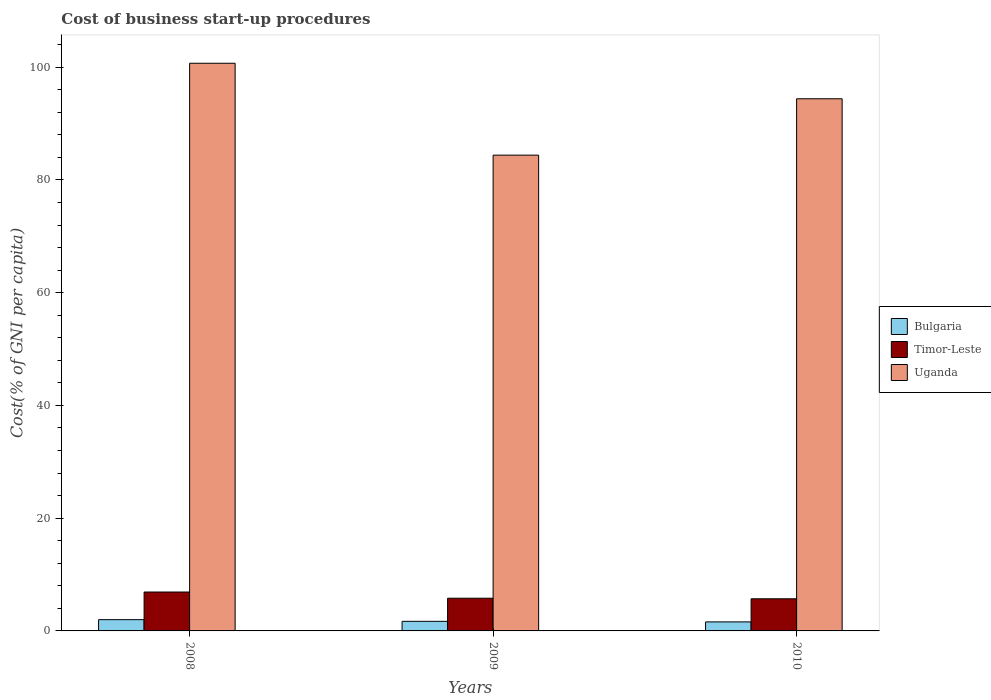How many different coloured bars are there?
Your answer should be compact. 3. How many groups of bars are there?
Provide a short and direct response. 3. Are the number of bars per tick equal to the number of legend labels?
Your answer should be very brief. Yes. Are the number of bars on each tick of the X-axis equal?
Provide a short and direct response. Yes. What is the label of the 2nd group of bars from the left?
Your answer should be compact. 2009. In how many cases, is the number of bars for a given year not equal to the number of legend labels?
Offer a terse response. 0. What is the cost of business start-up procedures in Uganda in 2010?
Your response must be concise. 94.4. Across all years, what is the maximum cost of business start-up procedures in Timor-Leste?
Provide a short and direct response. 6.9. In which year was the cost of business start-up procedures in Uganda maximum?
Ensure brevity in your answer.  2008. What is the total cost of business start-up procedures in Uganda in the graph?
Your answer should be compact. 279.5. What is the difference between the cost of business start-up procedures in Bulgaria in 2009 and that in 2010?
Give a very brief answer. 0.1. What is the difference between the cost of business start-up procedures in Uganda in 2008 and the cost of business start-up procedures in Bulgaria in 2009?
Give a very brief answer. 99. What is the average cost of business start-up procedures in Bulgaria per year?
Keep it short and to the point. 1.77. In the year 2008, what is the difference between the cost of business start-up procedures in Uganda and cost of business start-up procedures in Timor-Leste?
Provide a succinct answer. 93.8. What is the ratio of the cost of business start-up procedures in Bulgaria in 2008 to that in 2009?
Your response must be concise. 1.18. Is the difference between the cost of business start-up procedures in Uganda in 2008 and 2010 greater than the difference between the cost of business start-up procedures in Timor-Leste in 2008 and 2010?
Offer a very short reply. Yes. What is the difference between the highest and the second highest cost of business start-up procedures in Bulgaria?
Your answer should be very brief. 0.3. What is the difference between the highest and the lowest cost of business start-up procedures in Uganda?
Your answer should be very brief. 16.3. Is the sum of the cost of business start-up procedures in Uganda in 2009 and 2010 greater than the maximum cost of business start-up procedures in Bulgaria across all years?
Your response must be concise. Yes. What does the 1st bar from the right in 2008 represents?
Provide a succinct answer. Uganda. Is it the case that in every year, the sum of the cost of business start-up procedures in Timor-Leste and cost of business start-up procedures in Uganda is greater than the cost of business start-up procedures in Bulgaria?
Provide a short and direct response. Yes. How many bars are there?
Your answer should be very brief. 9. How many years are there in the graph?
Ensure brevity in your answer.  3. Does the graph contain any zero values?
Ensure brevity in your answer.  No. Does the graph contain grids?
Provide a succinct answer. No. What is the title of the graph?
Offer a terse response. Cost of business start-up procedures. What is the label or title of the X-axis?
Your answer should be very brief. Years. What is the label or title of the Y-axis?
Your answer should be compact. Cost(% of GNI per capita). What is the Cost(% of GNI per capita) of Timor-Leste in 2008?
Keep it short and to the point. 6.9. What is the Cost(% of GNI per capita) in Uganda in 2008?
Provide a succinct answer. 100.7. What is the Cost(% of GNI per capita) in Timor-Leste in 2009?
Offer a terse response. 5.8. What is the Cost(% of GNI per capita) in Uganda in 2009?
Offer a terse response. 84.4. What is the Cost(% of GNI per capita) of Bulgaria in 2010?
Make the answer very short. 1.6. What is the Cost(% of GNI per capita) in Timor-Leste in 2010?
Your answer should be very brief. 5.7. What is the Cost(% of GNI per capita) in Uganda in 2010?
Your response must be concise. 94.4. Across all years, what is the maximum Cost(% of GNI per capita) of Uganda?
Give a very brief answer. 100.7. Across all years, what is the minimum Cost(% of GNI per capita) in Bulgaria?
Make the answer very short. 1.6. Across all years, what is the minimum Cost(% of GNI per capita) of Uganda?
Offer a very short reply. 84.4. What is the total Cost(% of GNI per capita) of Bulgaria in the graph?
Your response must be concise. 5.3. What is the total Cost(% of GNI per capita) of Timor-Leste in the graph?
Provide a succinct answer. 18.4. What is the total Cost(% of GNI per capita) of Uganda in the graph?
Your answer should be very brief. 279.5. What is the difference between the Cost(% of GNI per capita) of Bulgaria in 2008 and that in 2010?
Provide a short and direct response. 0.4. What is the difference between the Cost(% of GNI per capita) in Timor-Leste in 2008 and that in 2010?
Your response must be concise. 1.2. What is the difference between the Cost(% of GNI per capita) of Bulgaria in 2009 and that in 2010?
Ensure brevity in your answer.  0.1. What is the difference between the Cost(% of GNI per capita) in Uganda in 2009 and that in 2010?
Make the answer very short. -10. What is the difference between the Cost(% of GNI per capita) in Bulgaria in 2008 and the Cost(% of GNI per capita) in Uganda in 2009?
Give a very brief answer. -82.4. What is the difference between the Cost(% of GNI per capita) in Timor-Leste in 2008 and the Cost(% of GNI per capita) in Uganda in 2009?
Ensure brevity in your answer.  -77.5. What is the difference between the Cost(% of GNI per capita) in Bulgaria in 2008 and the Cost(% of GNI per capita) in Timor-Leste in 2010?
Provide a succinct answer. -3.7. What is the difference between the Cost(% of GNI per capita) of Bulgaria in 2008 and the Cost(% of GNI per capita) of Uganda in 2010?
Keep it short and to the point. -92.4. What is the difference between the Cost(% of GNI per capita) of Timor-Leste in 2008 and the Cost(% of GNI per capita) of Uganda in 2010?
Offer a terse response. -87.5. What is the difference between the Cost(% of GNI per capita) of Bulgaria in 2009 and the Cost(% of GNI per capita) of Uganda in 2010?
Offer a terse response. -92.7. What is the difference between the Cost(% of GNI per capita) in Timor-Leste in 2009 and the Cost(% of GNI per capita) in Uganda in 2010?
Provide a short and direct response. -88.6. What is the average Cost(% of GNI per capita) in Bulgaria per year?
Offer a very short reply. 1.77. What is the average Cost(% of GNI per capita) of Timor-Leste per year?
Your answer should be compact. 6.13. What is the average Cost(% of GNI per capita) in Uganda per year?
Provide a succinct answer. 93.17. In the year 2008, what is the difference between the Cost(% of GNI per capita) of Bulgaria and Cost(% of GNI per capita) of Uganda?
Make the answer very short. -98.7. In the year 2008, what is the difference between the Cost(% of GNI per capita) in Timor-Leste and Cost(% of GNI per capita) in Uganda?
Ensure brevity in your answer.  -93.8. In the year 2009, what is the difference between the Cost(% of GNI per capita) of Bulgaria and Cost(% of GNI per capita) of Uganda?
Your answer should be very brief. -82.7. In the year 2009, what is the difference between the Cost(% of GNI per capita) of Timor-Leste and Cost(% of GNI per capita) of Uganda?
Offer a very short reply. -78.6. In the year 2010, what is the difference between the Cost(% of GNI per capita) of Bulgaria and Cost(% of GNI per capita) of Timor-Leste?
Your response must be concise. -4.1. In the year 2010, what is the difference between the Cost(% of GNI per capita) in Bulgaria and Cost(% of GNI per capita) in Uganda?
Keep it short and to the point. -92.8. In the year 2010, what is the difference between the Cost(% of GNI per capita) of Timor-Leste and Cost(% of GNI per capita) of Uganda?
Your response must be concise. -88.7. What is the ratio of the Cost(% of GNI per capita) in Bulgaria in 2008 to that in 2009?
Your response must be concise. 1.18. What is the ratio of the Cost(% of GNI per capita) of Timor-Leste in 2008 to that in 2009?
Your answer should be compact. 1.19. What is the ratio of the Cost(% of GNI per capita) of Uganda in 2008 to that in 2009?
Provide a succinct answer. 1.19. What is the ratio of the Cost(% of GNI per capita) of Timor-Leste in 2008 to that in 2010?
Provide a short and direct response. 1.21. What is the ratio of the Cost(% of GNI per capita) of Uganda in 2008 to that in 2010?
Give a very brief answer. 1.07. What is the ratio of the Cost(% of GNI per capita) in Timor-Leste in 2009 to that in 2010?
Keep it short and to the point. 1.02. What is the ratio of the Cost(% of GNI per capita) in Uganda in 2009 to that in 2010?
Your answer should be very brief. 0.89. What is the difference between the highest and the lowest Cost(% of GNI per capita) in Bulgaria?
Ensure brevity in your answer.  0.4. What is the difference between the highest and the lowest Cost(% of GNI per capita) of Timor-Leste?
Give a very brief answer. 1.2. What is the difference between the highest and the lowest Cost(% of GNI per capita) of Uganda?
Ensure brevity in your answer.  16.3. 